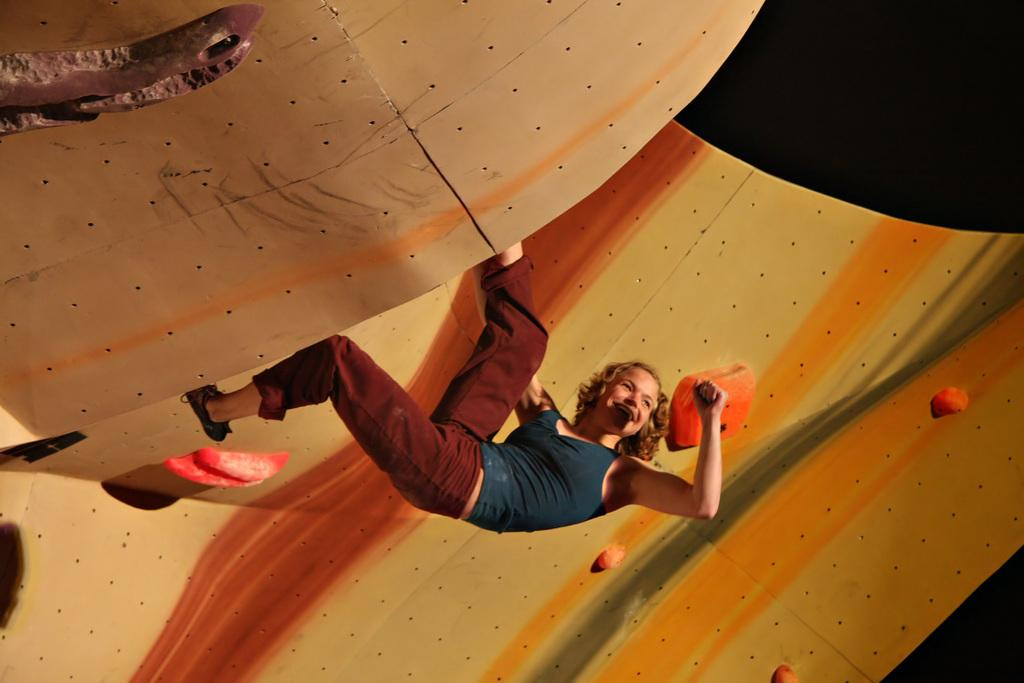What is the main subject of the image? There is a person in the image. What is the person wearing? The person is wearing clothes. What activity is the person engaged in? The person is climbing a wall. What type of plant is being digested by the person in the image? There is no plant or digestion mentioned in the image; it features a person climbing a wall. How many slaves are visible in the image? There is no mention of slaves in the image; it only shows a person climbing a wall. 